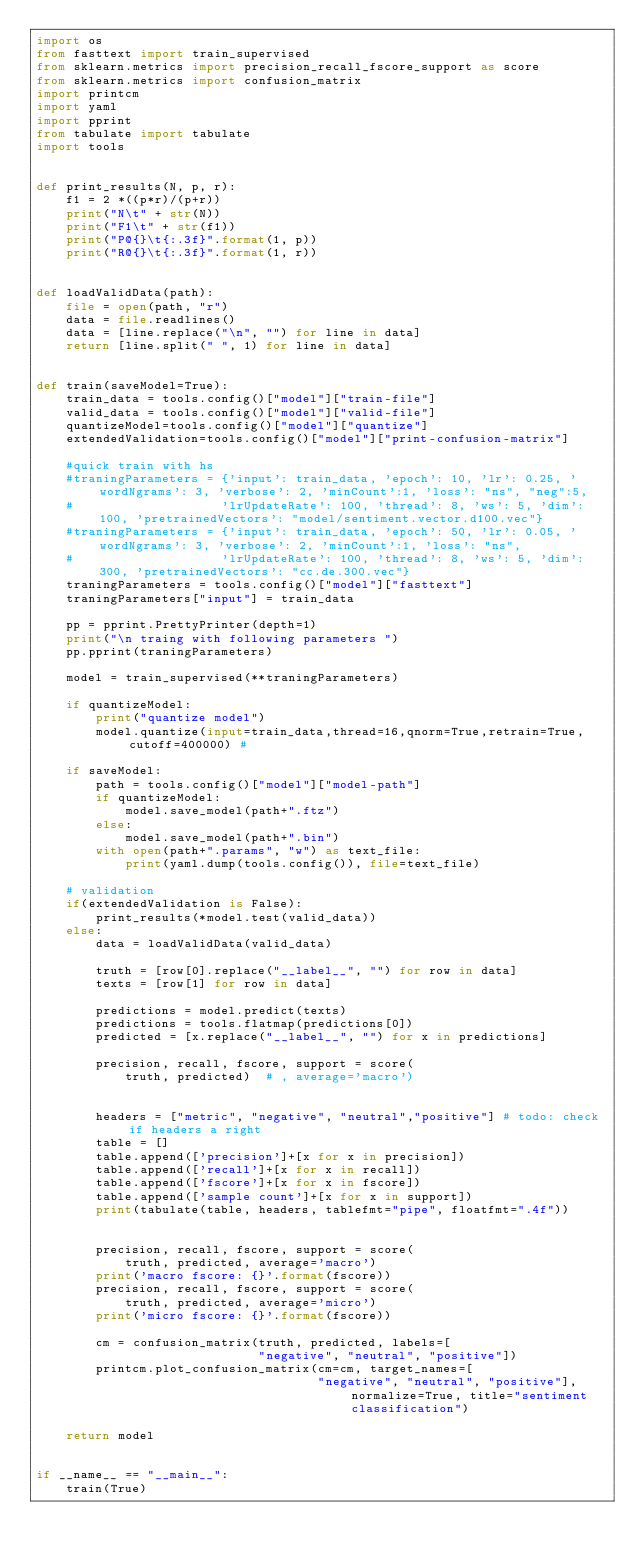Convert code to text. <code><loc_0><loc_0><loc_500><loc_500><_Python_>import os
from fasttext import train_supervised
from sklearn.metrics import precision_recall_fscore_support as score
from sklearn.metrics import confusion_matrix
import printcm
import yaml
import pprint
from tabulate import tabulate
import tools


def print_results(N, p, r):
    f1 = 2 *((p*r)/(p+r))
    print("N\t" + str(N))
    print("F1\t" + str(f1))
    print("P@{}\t{:.3f}".format(1, p))
    print("R@{}\t{:.3f}".format(1, r))


def loadValidData(path):
    file = open(path, "r")
    data = file.readlines()
    data = [line.replace("\n", "") for line in data]
    return [line.split(" ", 1) for line in data]


def train(saveModel=True):
    train_data = tools.config()["model"]["train-file"]
    valid_data = tools.config()["model"]["valid-file"]
    quantizeModel=tools.config()["model"]["quantize"]    
    extendedValidation=tools.config()["model"]["print-confusion-matrix"]
    
    #quick train with hs
    #traningParameters = {'input': train_data, 'epoch': 10, 'lr': 0.25, 'wordNgrams': 3, 'verbose': 2, 'minCount':1, 'loss': "ns", "neg":5,
    #                    'lrUpdateRate': 100, 'thread': 8, 'ws': 5, 'dim': 100, 'pretrainedVectors': "model/sentiment.vector.d100.vec"}
    #traningParameters = {'input': train_data, 'epoch': 50, 'lr': 0.05, 'wordNgrams': 3, 'verbose': 2, 'minCount':1, 'loss': "ns",
    #                    'lrUpdateRate': 100, 'thread': 8, 'ws': 5, 'dim': 300, 'pretrainedVectors': "cc.de.300.vec"}                        
    traningParameters = tools.config()["model"]["fasttext"]
    traningParameters["input"] = train_data  

    pp = pprint.PrettyPrinter(depth=1)
    print("\n traing with following parameters ")
    pp.pprint(traningParameters)

    model = train_supervised(**traningParameters)

    if quantizeModel:
        print("quantize model")
        model.quantize(input=train_data,thread=16,qnorm=True,retrain=True,cutoff=400000) #

    if saveModel:
        path = tools.config()["model"]["model-path"]
        if quantizeModel:
            model.save_model(path+".ftz")
        else:
            model.save_model(path+".bin")        
        with open(path+".params", "w") as text_file:
            print(yaml.dump(tools.config()), file=text_file)  

    # validation
    if(extendedValidation is False):
        print_results(*model.test(valid_data))
    else:
        data = loadValidData(valid_data)

        truth = [row[0].replace("__label__", "") for row in data]        
        texts = [row[1] for row in data]

        predictions = model.predict(texts)
        predictions = tools.flatmap(predictions[0])
        predicted = [x.replace("__label__", "") for x in predictions]
 
        precision, recall, fscore, support = score(
            truth, predicted)  # , average='macro')


        headers = ["metric", "negative", "neutral","positive"] # todo: check if headers a right
        table = []
        table.append(['precision']+[x for x in precision])
        table.append(['recall']+[x for x in recall])
        table.append(['fscore']+[x for x in fscore])
        table.append(['sample count']+[x for x in support])
        print(tabulate(table, headers, tablefmt="pipe", floatfmt=".4f"))
  

        precision, recall, fscore, support = score(
            truth, predicted, average='macro')
        print('macro fscore: {}'.format(fscore))
        precision, recall, fscore, support = score(
            truth, predicted, average='micro')
        print('micro fscore: {}'.format(fscore))

        cm = confusion_matrix(truth, predicted, labels=[
                              "negative", "neutral", "positive"])
        printcm.plot_confusion_matrix(cm=cm, target_names=[
                                      "negative", "neutral", "positive"], normalize=True, title="sentiment classification")

    return model


if __name__ == "__main__":
    train(True)
</code> 